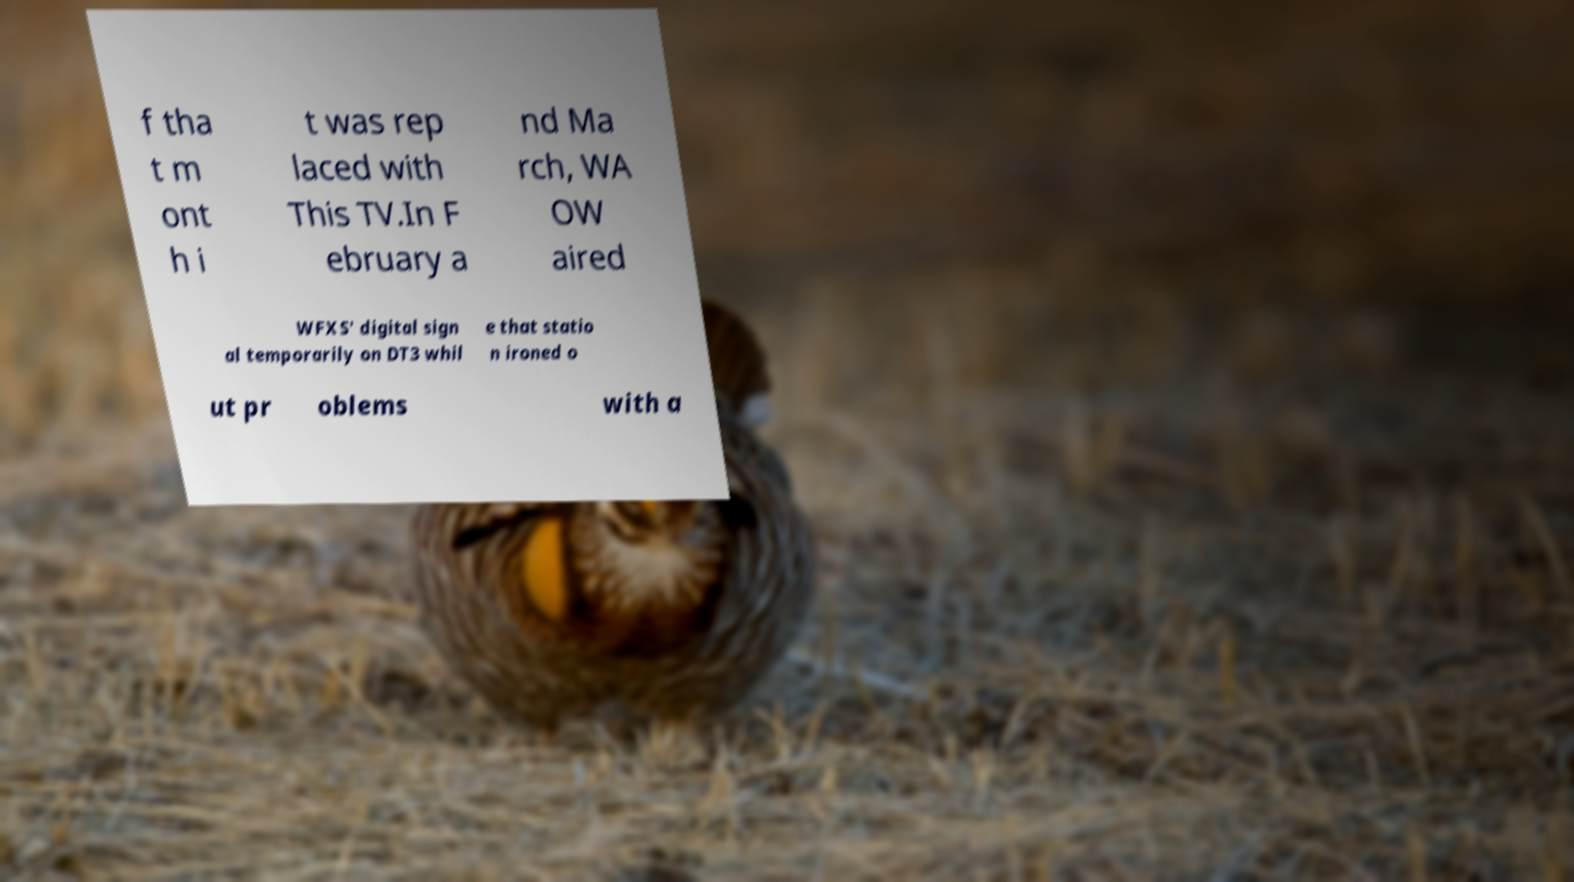There's text embedded in this image that I need extracted. Can you transcribe it verbatim? f tha t m ont h i t was rep laced with This TV.In F ebruary a nd Ma rch, WA OW aired WFXS' digital sign al temporarily on DT3 whil e that statio n ironed o ut pr oblems with a 